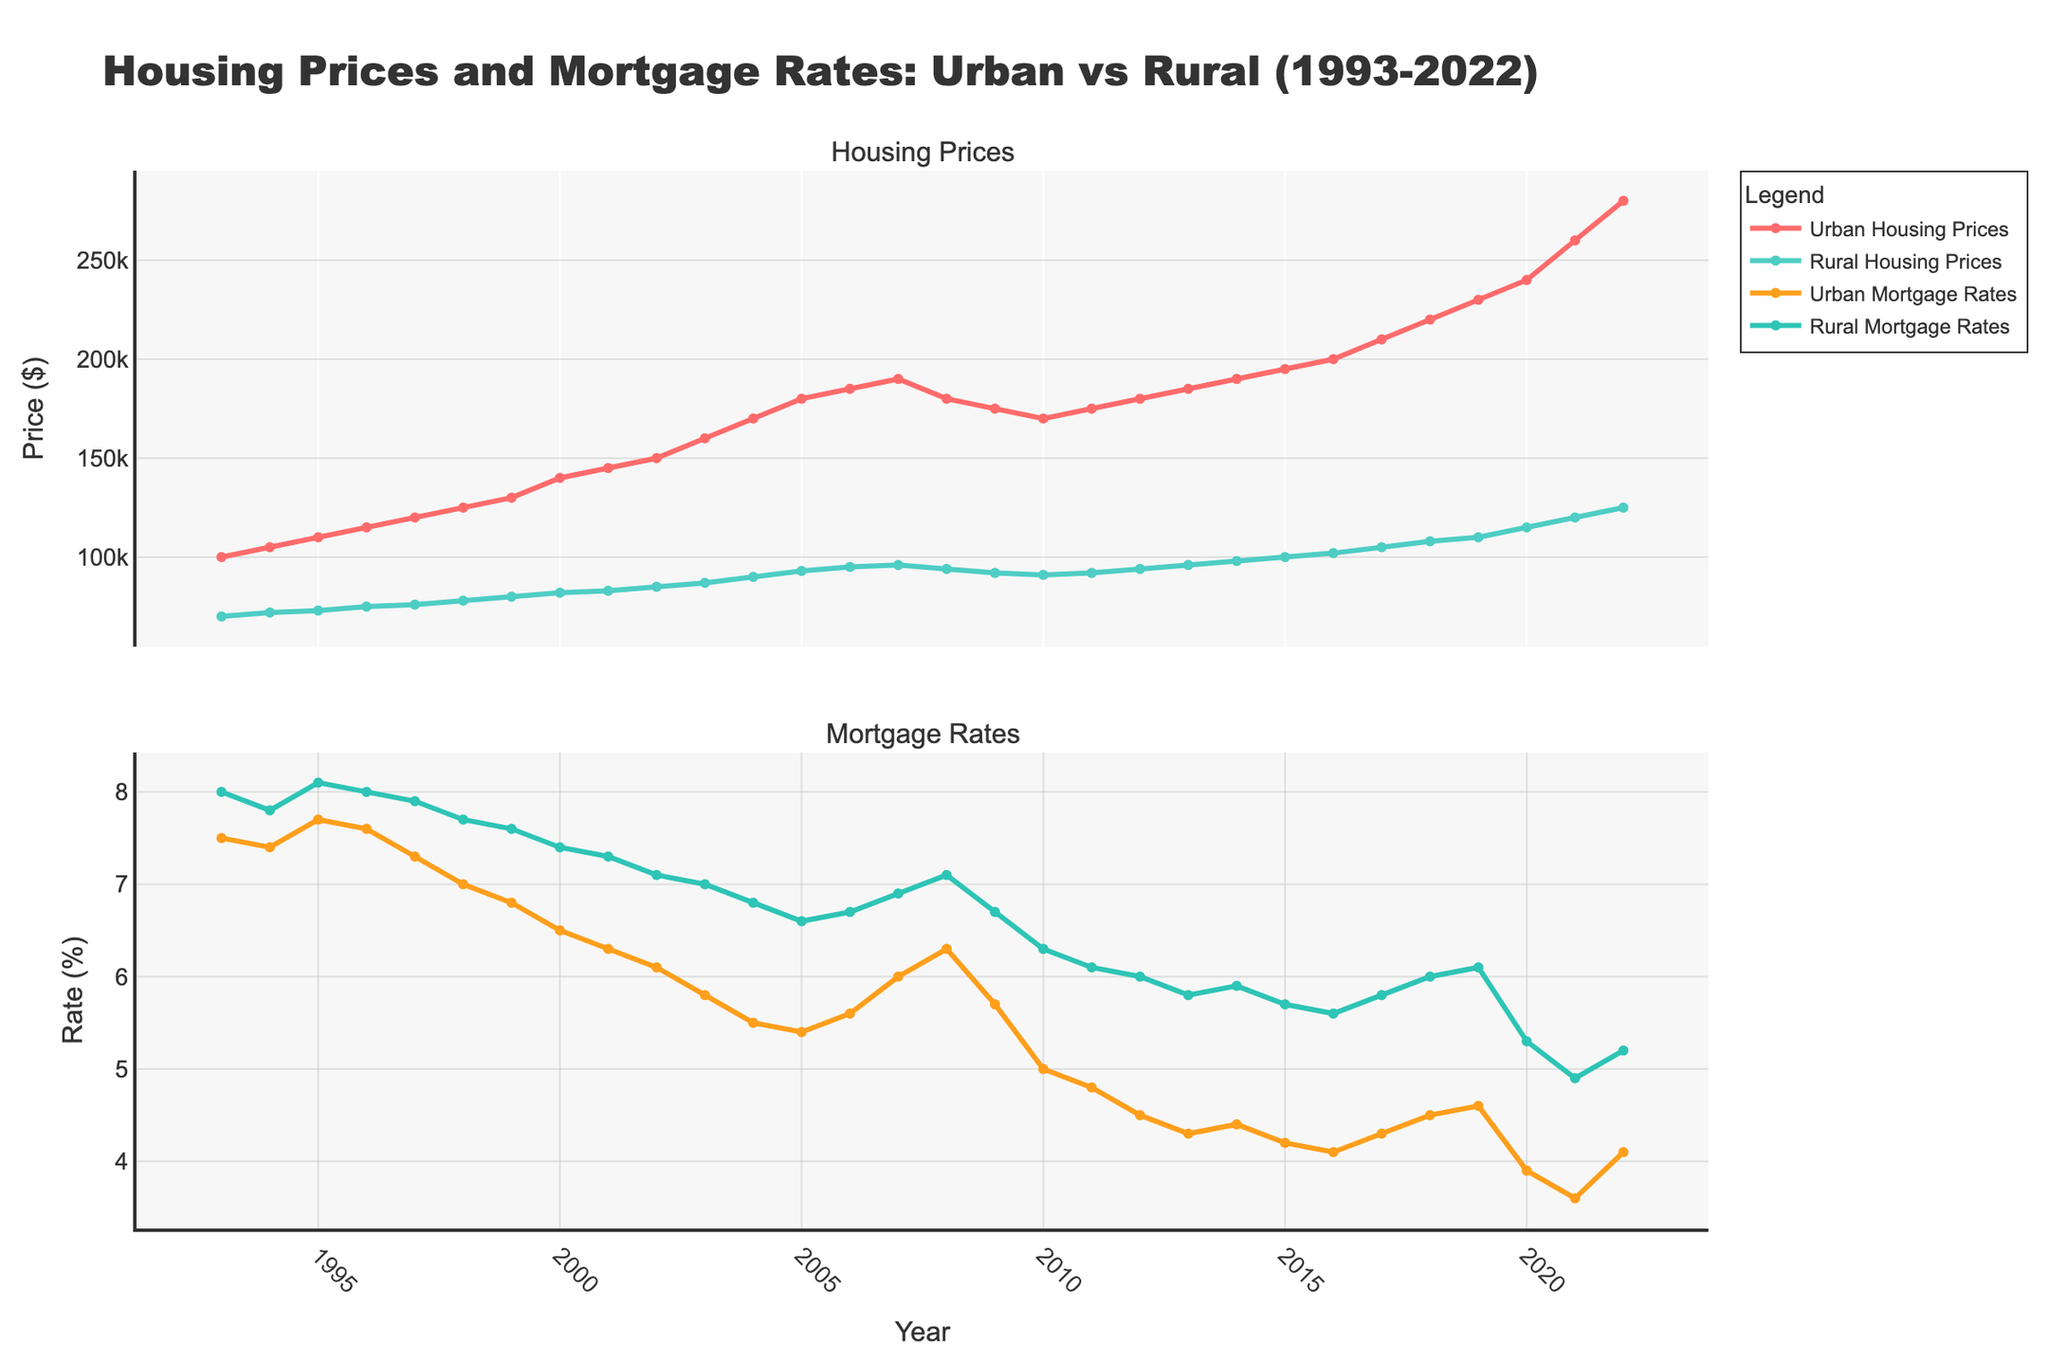How do urban housing prices compare to rural housing prices in 1993? Check the plot for the values of urban and rural housing prices in 1993. Urban housing prices are $100,000, and rural housing prices are $70,000. Hence, urban housing prices are higher.
Answer: Urban housing prices are higher than rural housing prices What are the highest mortgage rates recorded in both urban and rural areas, and in which years were they recorded? Look at the peaks in the mortgage rates' time series. For urban areas, the highest rate is 7.7% in 1995. For rural areas, it's 8.1% in 1995.
Answer: 7.7% in 1995 (urban), 8.1% in 1995 (rural) Calculate the difference between urban and rural housing prices in 2022. For 2022, urban housing prices are $280,000, and rural housing prices are $125,000. The difference is $280,000 - $125,000 = $155,000.
Answer: $155,000 Between 2008 and 2012, how did the trend of urban housing prices compare to rural housing prices? Examine the trend lines between these years for both urban and rural housing prices. Both urban and rural housing prices saw a decline around 2009 and then started to increase again, showing a similar trend.
Answer: Similar trend Which year had the lowest mortgage rate in urban areas, and what was the rate? Identify the lowest point on the urban mortgage rate plot. The lowest mortgage rate in urban areas is 3.6% in 2021.
Answer: 2021, 3.6% How much did urban housing prices increase from 2000 to 2005? Note the urban housing prices in 2000 and 2005. The price in 2000 is $140,000 and in 2005 is $180,000. The increase is $180,000 - $140,000 = $40,000.
Answer: $40,000 Compare the mortgage rates in urban and rural areas in 2010. Read the mortgage rates from the plot for both areas in 2010. Urban mortgage rate in 2010 is 5.0%, and the rural mortgage rate is 6.3%. Urban mortgage rates are lower.
Answer: Urban mortgage rates are lower Did rural housing prices ever surpass urban housing prices in the data provided? Examine the entire time series for any overlap. There are no instances where rural housing prices surpass urban housing prices over the given period.
Answer: No What is the general trend of mortgage rates from 1993 to 2022 in urban areas? Observe the overall direction of the urban mortgage rate plot over the period. The general trend shows a decline in mortgage rates from 7.5% in 1993 to 4.1% in 2022.
Answer: General decline In which year did urban housing prices reach $200,000? Find the year where the urban housing price plot intersects the $200,000 mark. Urban housing prices reached $200,000 in 2016.
Answer: 2016 